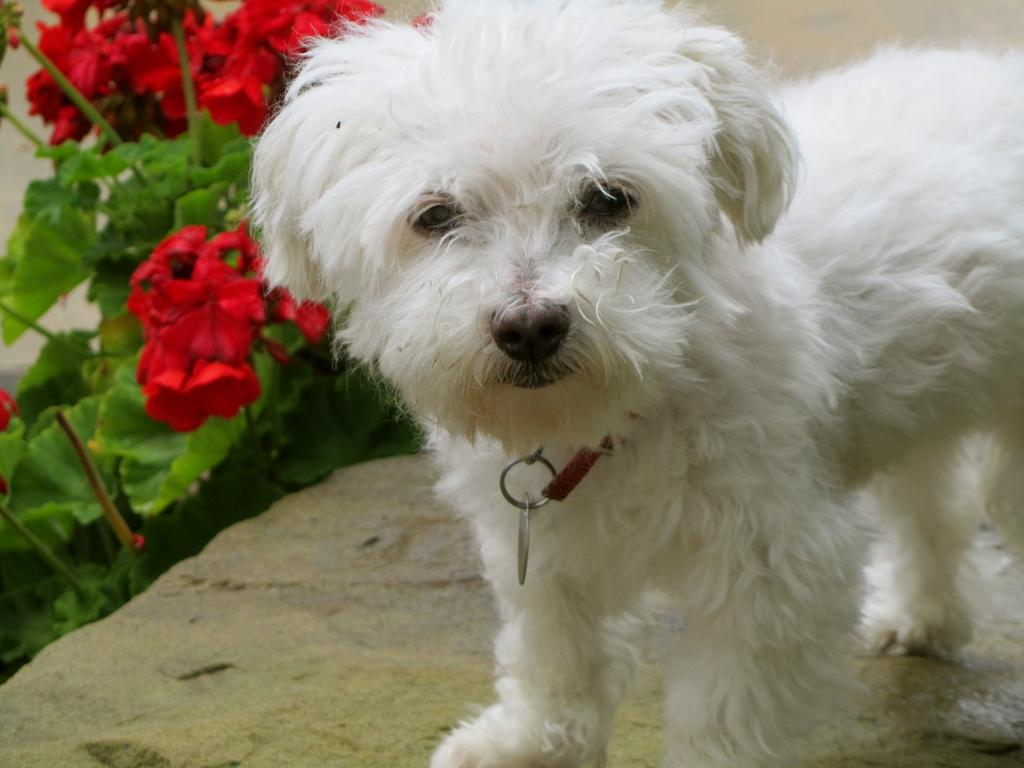What type of animal is in the image? There is a white-colored dog in the image. What can be seen in the background of the image? There are red-colored flowers and green leaves in the background of the image. What language is the dog speaking in the image? Dogs do not speak human languages, so there is no language spoken by the dog in the image. 